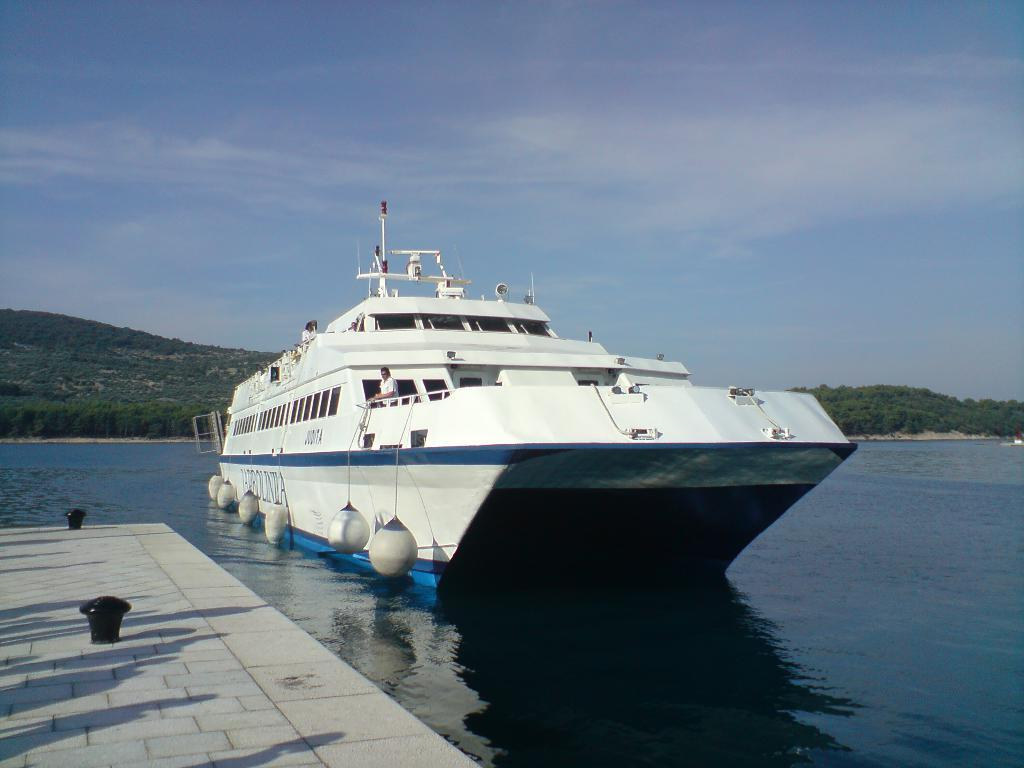What is the main subject in the center of the image? There is a ship in the center of the image. Where is the ship located? The ship is on the water. What can be seen at the bottom side of the image? There is a dock at the bottom side of the image. What type of environment is visible in the background of the image? There is greenery in the background of the image. What type of watch can be seen on the ship's captain in the image? There is no watch visible in the image, nor is there a ship's captain present. What is the aftermath of the storm in the image? There is no storm or any indication of an aftermath in the image. 